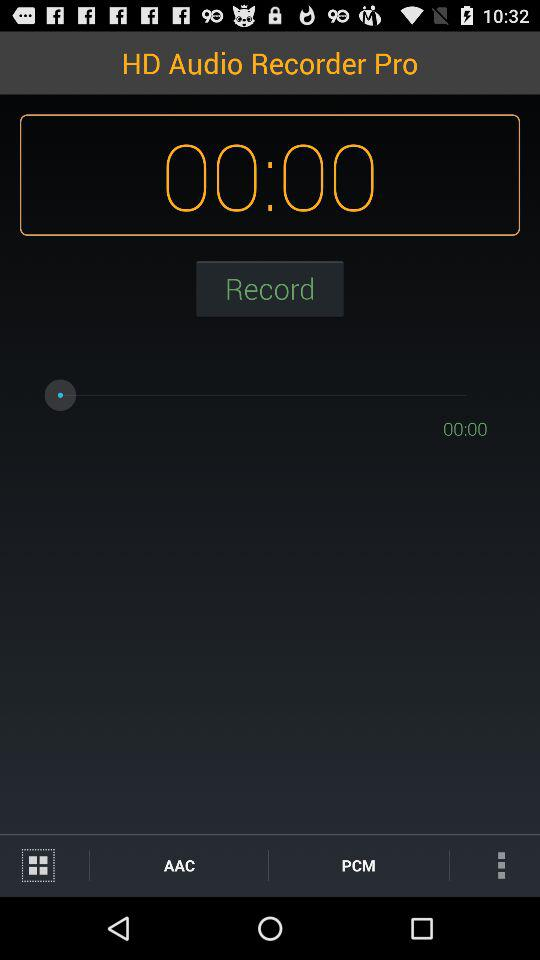Who is using "HD Audio Recorder Pro"?
When the provided information is insufficient, respond with <no answer>. <no answer> 